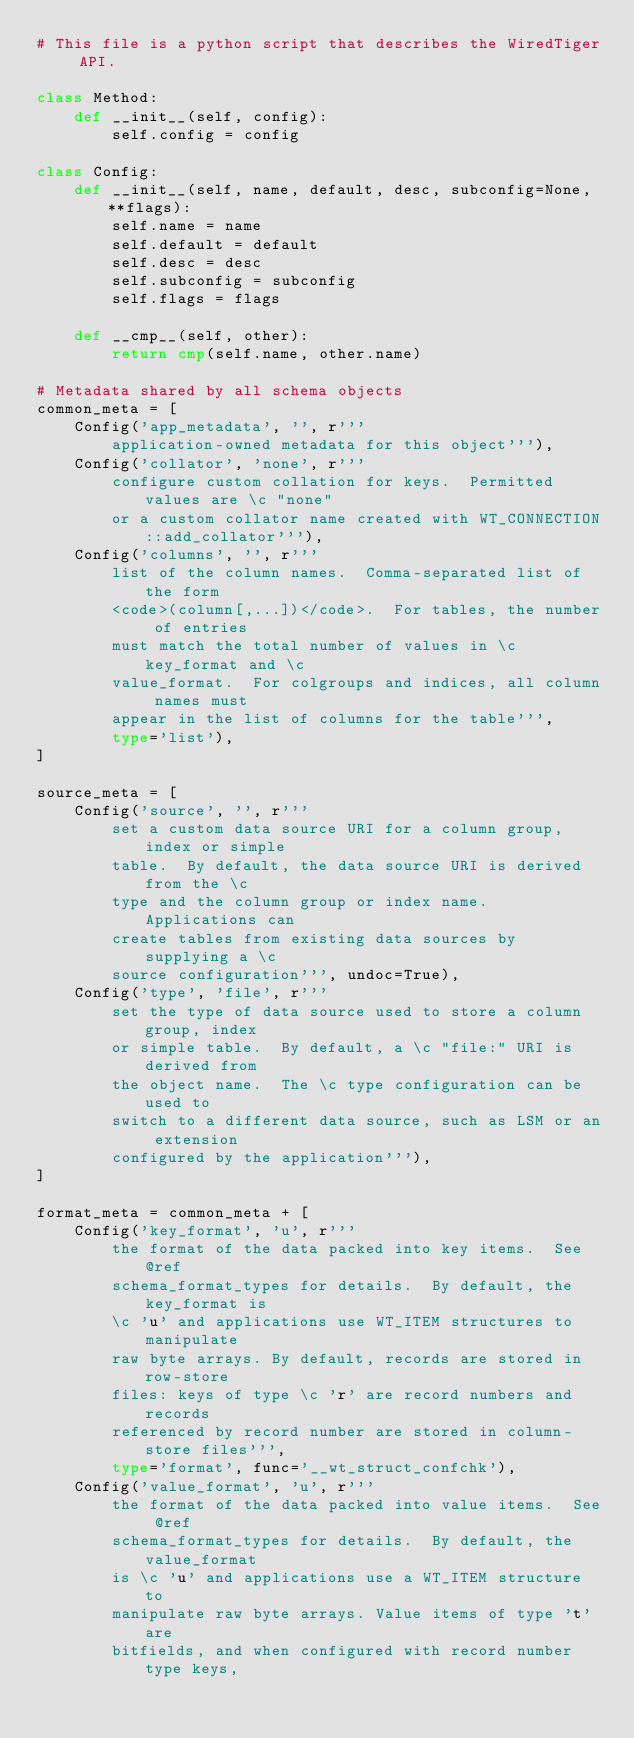Convert code to text. <code><loc_0><loc_0><loc_500><loc_500><_Python_># This file is a python script that describes the WiredTiger API.

class Method:
    def __init__(self, config):
        self.config = config

class Config:
    def __init__(self, name, default, desc, subconfig=None, **flags):
        self.name = name
        self.default = default
        self.desc = desc
        self.subconfig = subconfig
        self.flags = flags

    def __cmp__(self, other):
        return cmp(self.name, other.name)

# Metadata shared by all schema objects
common_meta = [
    Config('app_metadata', '', r'''
        application-owned metadata for this object'''),
    Config('collator', 'none', r'''
        configure custom collation for keys.  Permitted values are \c "none"
        or a custom collator name created with WT_CONNECTION::add_collator'''),
    Config('columns', '', r'''
        list of the column names.  Comma-separated list of the form
        <code>(column[,...])</code>.  For tables, the number of entries
        must match the total number of values in \c key_format and \c
        value_format.  For colgroups and indices, all column names must
        appear in the list of columns for the table''',
        type='list'),
]

source_meta = [
    Config('source', '', r'''
        set a custom data source URI for a column group, index or simple
        table.  By default, the data source URI is derived from the \c
        type and the column group or index name.  Applications can
        create tables from existing data sources by supplying a \c
        source configuration''', undoc=True),
    Config('type', 'file', r'''
        set the type of data source used to store a column group, index
        or simple table.  By default, a \c "file:" URI is derived from
        the object name.  The \c type configuration can be used to
        switch to a different data source, such as LSM or an extension
        configured by the application'''),
]

format_meta = common_meta + [
    Config('key_format', 'u', r'''
        the format of the data packed into key items.  See @ref
        schema_format_types for details.  By default, the key_format is
        \c 'u' and applications use WT_ITEM structures to manipulate
        raw byte arrays. By default, records are stored in row-store
        files: keys of type \c 'r' are record numbers and records
        referenced by record number are stored in column-store files''',
        type='format', func='__wt_struct_confchk'),
    Config('value_format', 'u', r'''
        the format of the data packed into value items.  See @ref
        schema_format_types for details.  By default, the value_format
        is \c 'u' and applications use a WT_ITEM structure to
        manipulate raw byte arrays. Value items of type 't' are
        bitfields, and when configured with record number type keys,</code> 